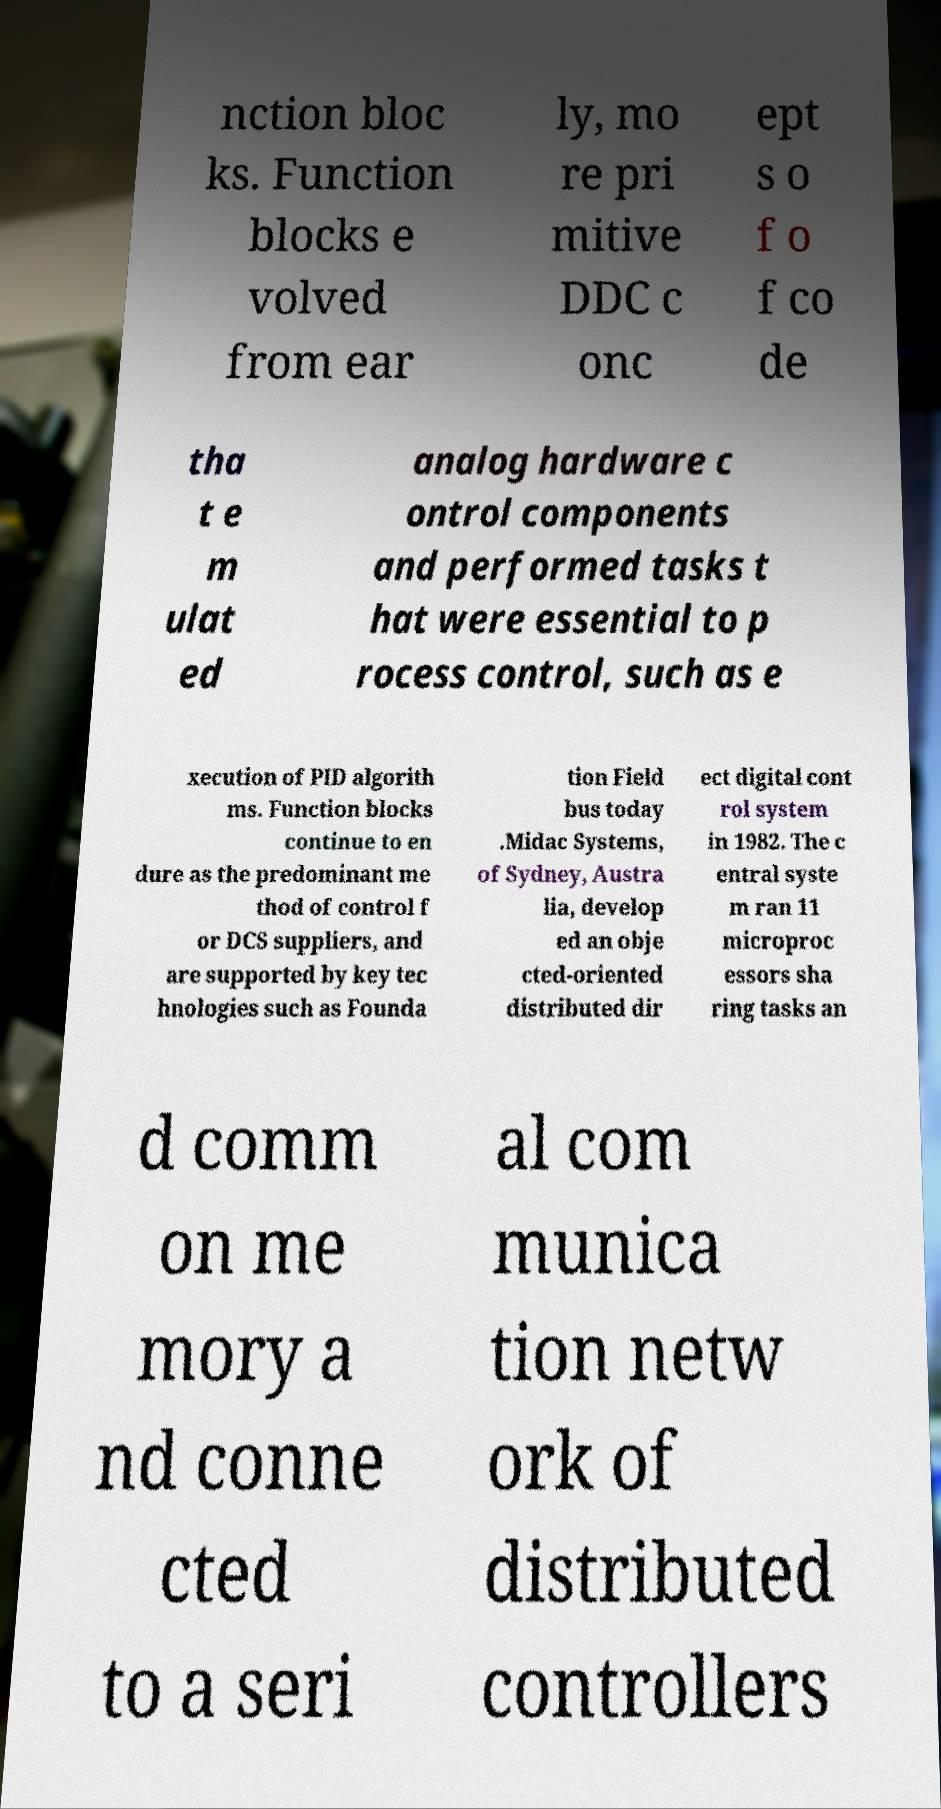Please identify and transcribe the text found in this image. nction bloc ks. Function blocks e volved from ear ly, mo re pri mitive DDC c onc ept s o f o f co de tha t e m ulat ed analog hardware c ontrol components and performed tasks t hat were essential to p rocess control, such as e xecution of PID algorith ms. Function blocks continue to en dure as the predominant me thod of control f or DCS suppliers, and are supported by key tec hnologies such as Founda tion Field bus today .Midac Systems, of Sydney, Austra lia, develop ed an obje cted-oriented distributed dir ect digital cont rol system in 1982. The c entral syste m ran 11 microproc essors sha ring tasks an d comm on me mory a nd conne cted to a seri al com munica tion netw ork of distributed controllers 